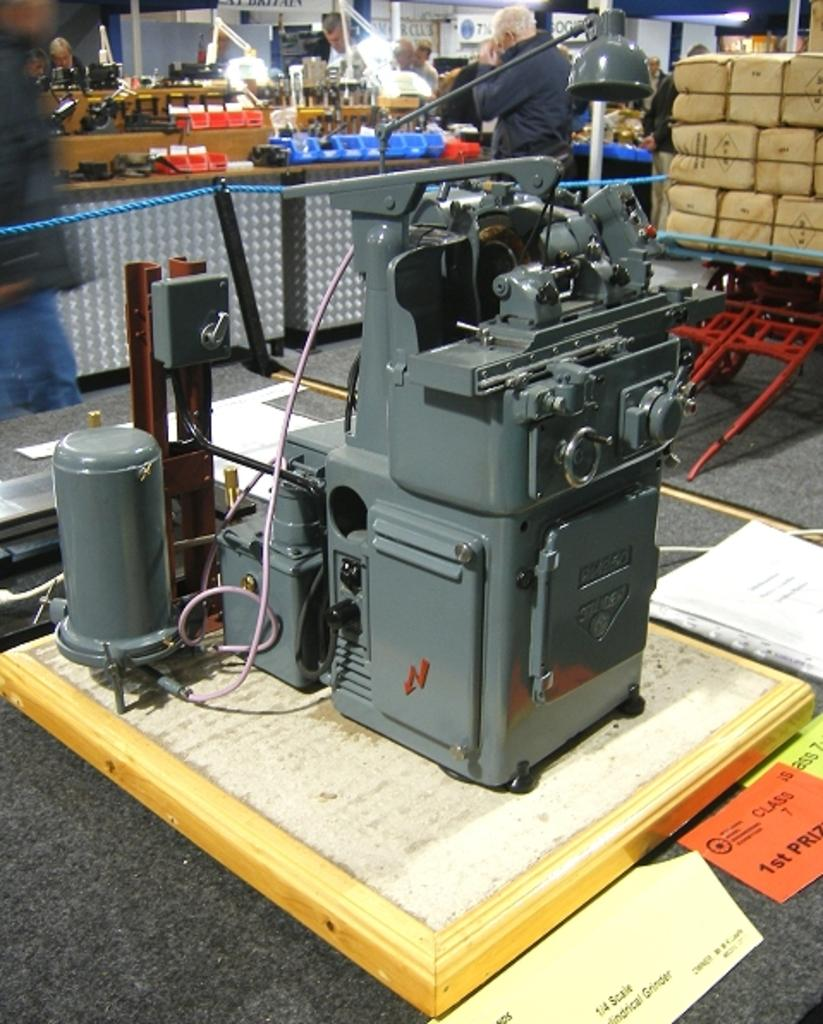What is the main object on the table in the image? There is a machine on the table in the image. What can be seen in the background of the image? There are people walking and objects in the background of the image. Can you describe the objects in the background? There are packets in the background of the image. What type of frame is holding the jewel in the image? There is no frame or jewel present in the image. 